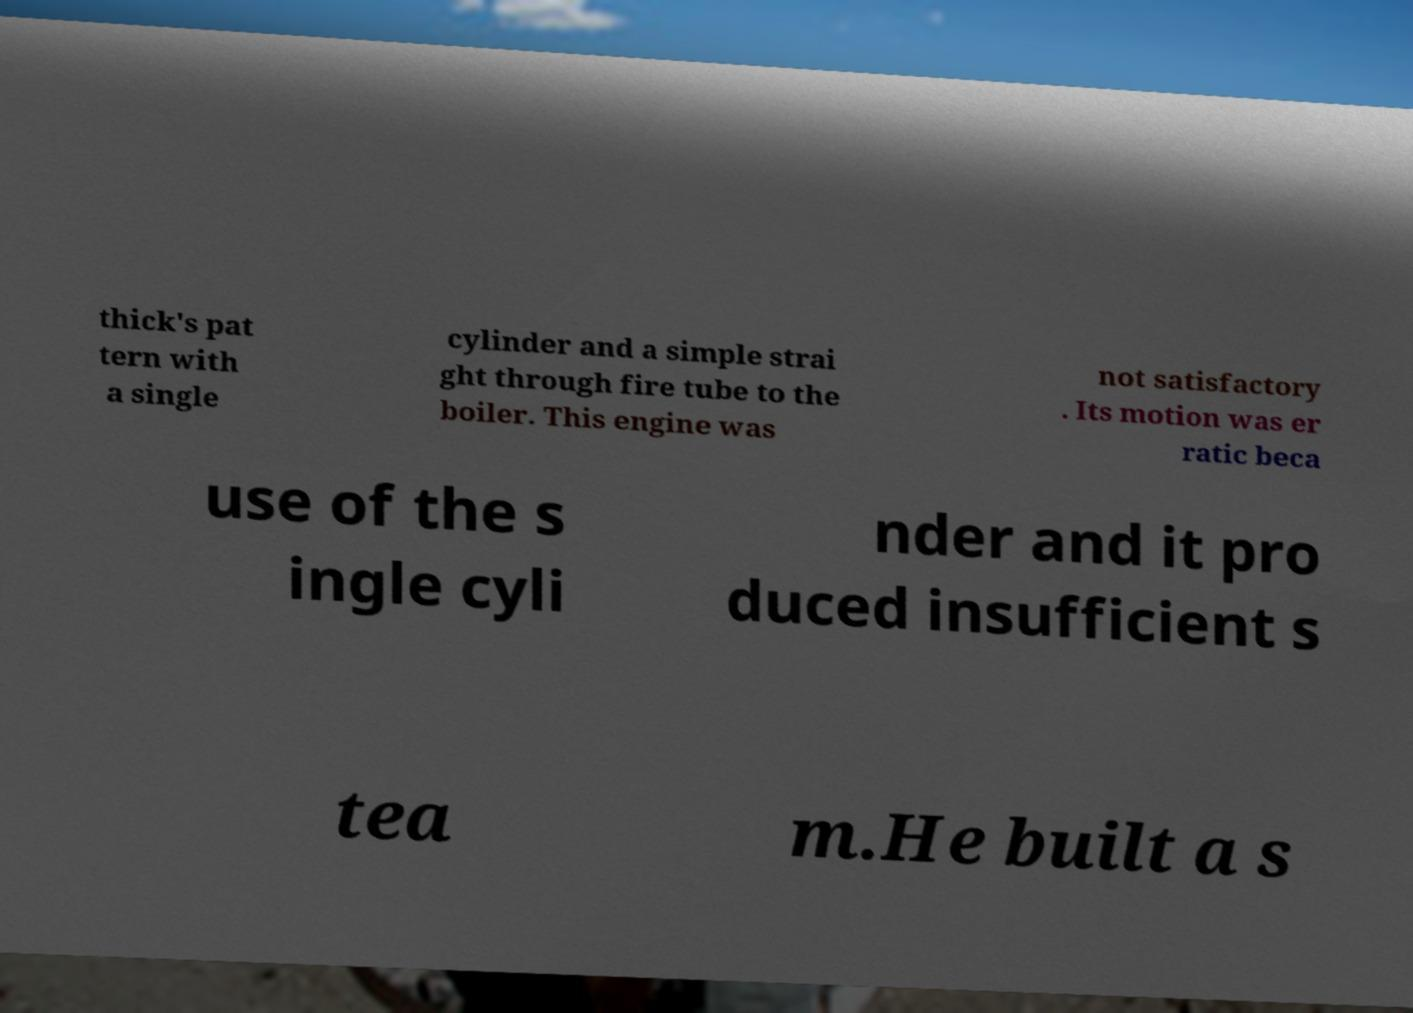For documentation purposes, I need the text within this image transcribed. Could you provide that? thick's pat tern with a single cylinder and a simple strai ght through fire tube to the boiler. This engine was not satisfactory . Its motion was er ratic beca use of the s ingle cyli nder and it pro duced insufficient s tea m.He built a s 